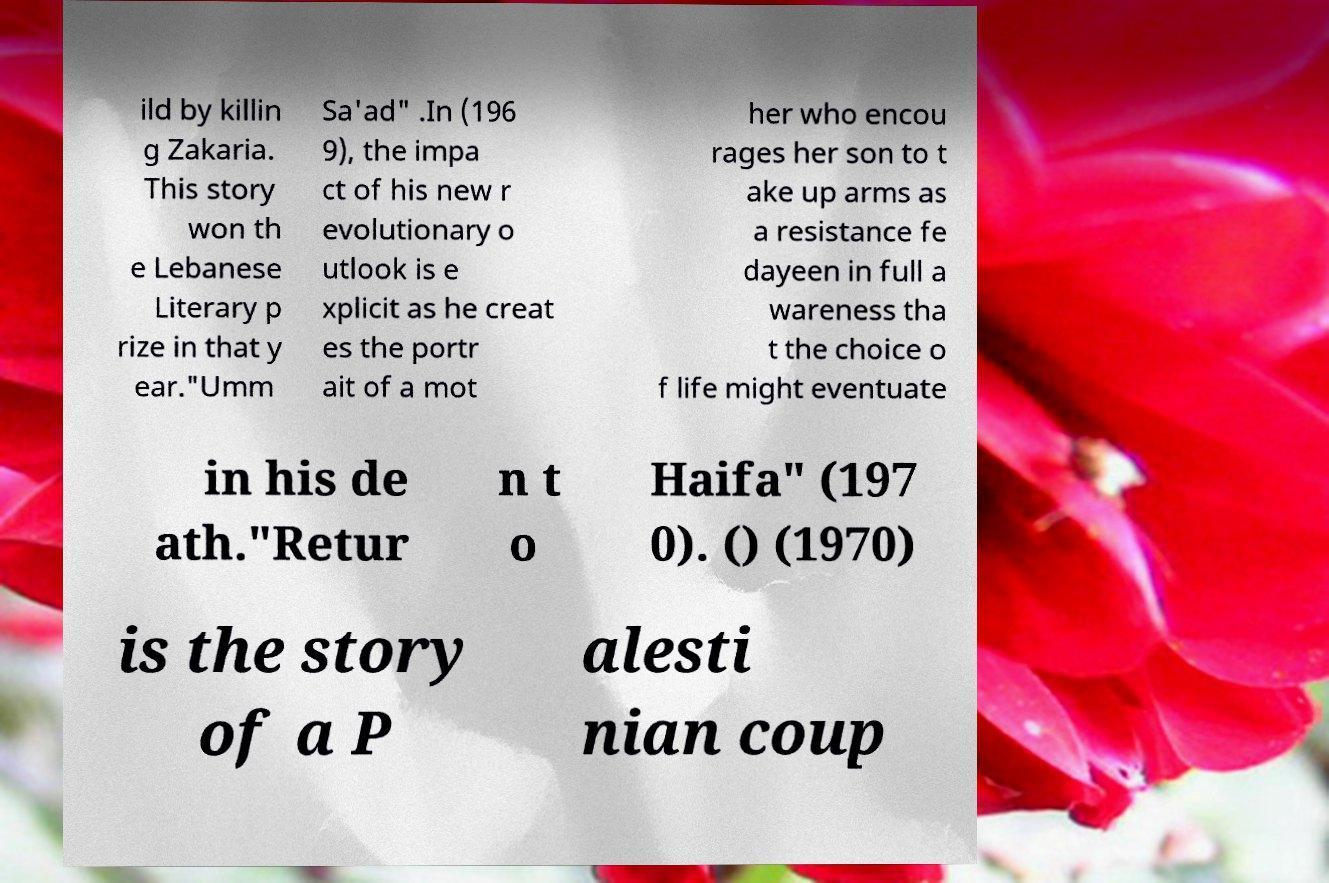Please read and relay the text visible in this image. What does it say? ild by killin g Zakaria. This story won th e Lebanese Literary p rize in that y ear."Umm Sa'ad" .In (196 9), the impa ct of his new r evolutionary o utlook is e xplicit as he creat es the portr ait of a mot her who encou rages her son to t ake up arms as a resistance fe dayeen in full a wareness tha t the choice o f life might eventuate in his de ath."Retur n t o Haifa" (197 0). () (1970) is the story of a P alesti nian coup 